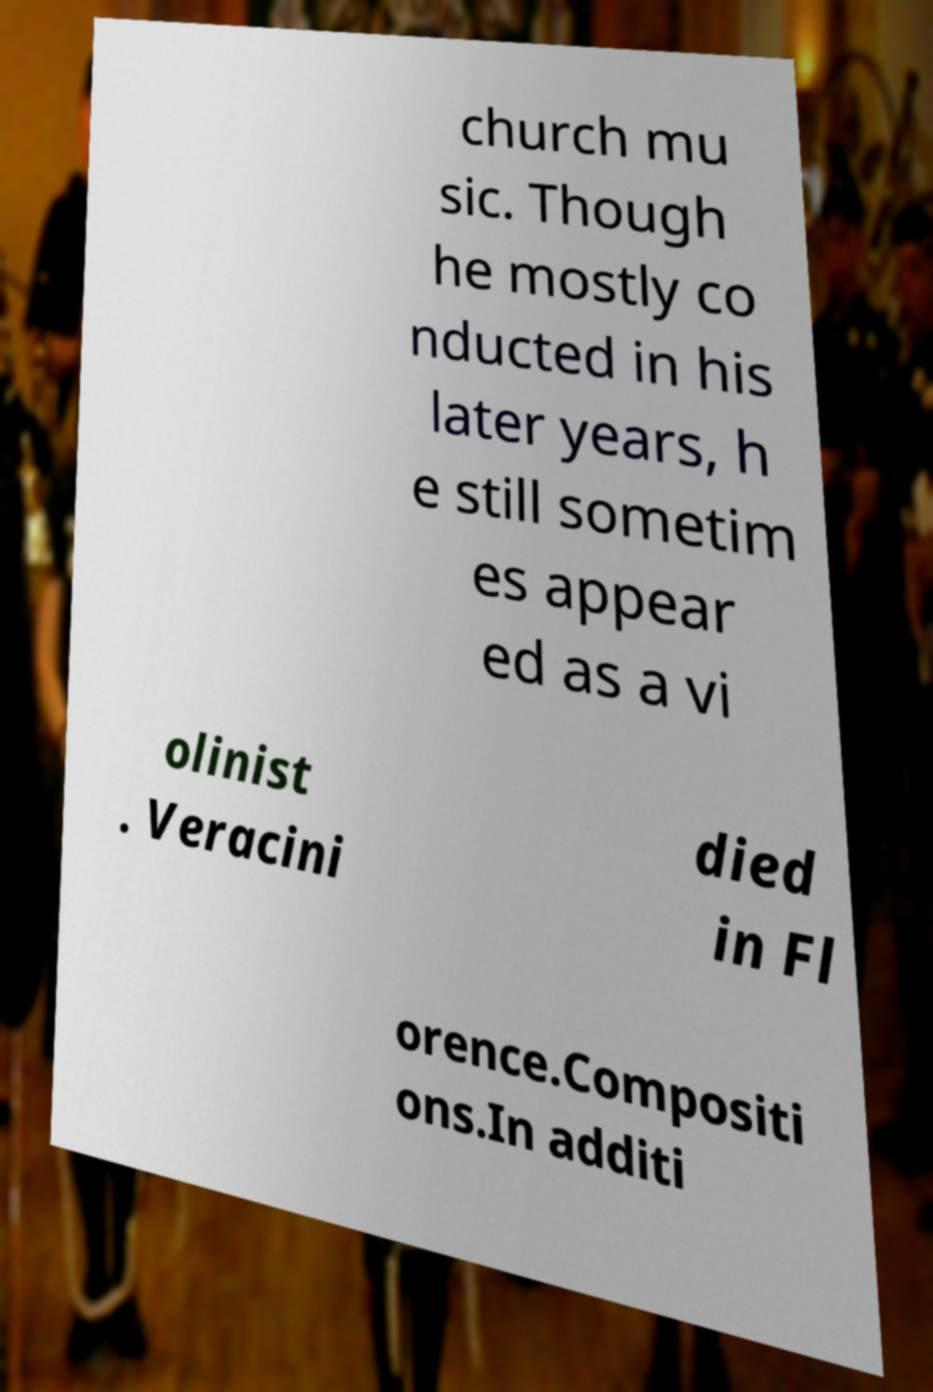I need the written content from this picture converted into text. Can you do that? church mu sic. Though he mostly co nducted in his later years, h e still sometim es appear ed as a vi olinist . Veracini died in Fl orence.Compositi ons.In additi 